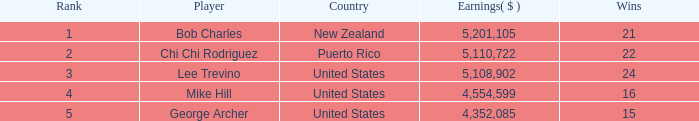What is the lowest level of Earnings($) to have a Wins value of 22 and a Rank lower than 2? None. 